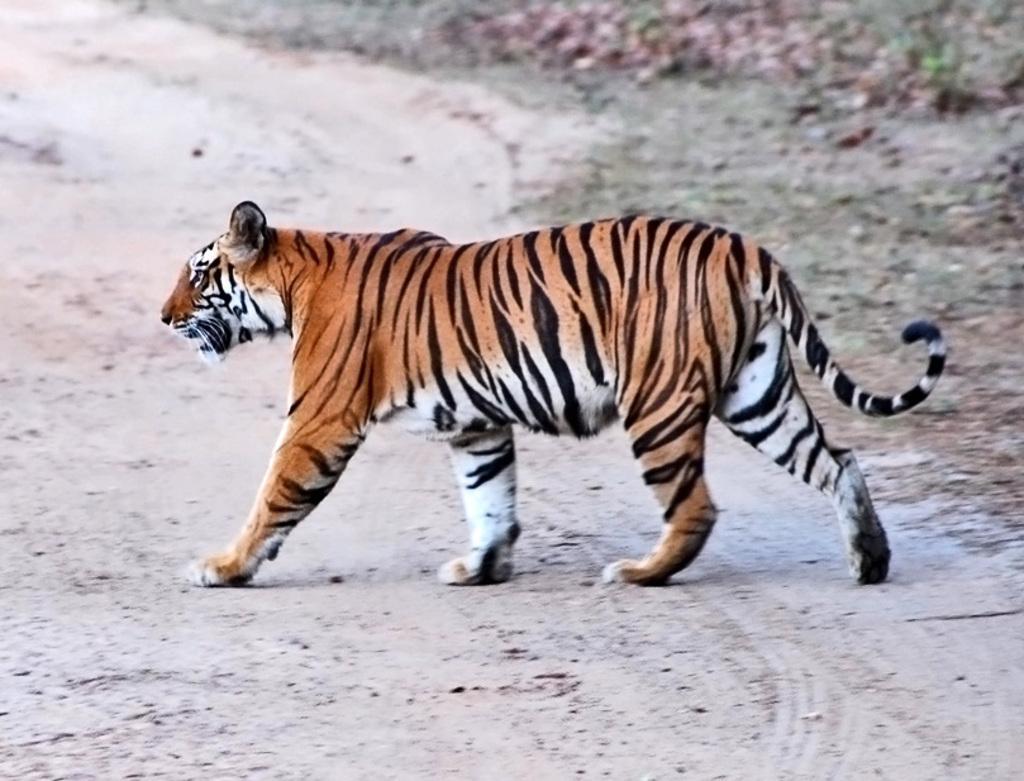How would you summarize this image in a sentence or two? In this picture, we can see an animal on the ground, and we can see the blurred background. 